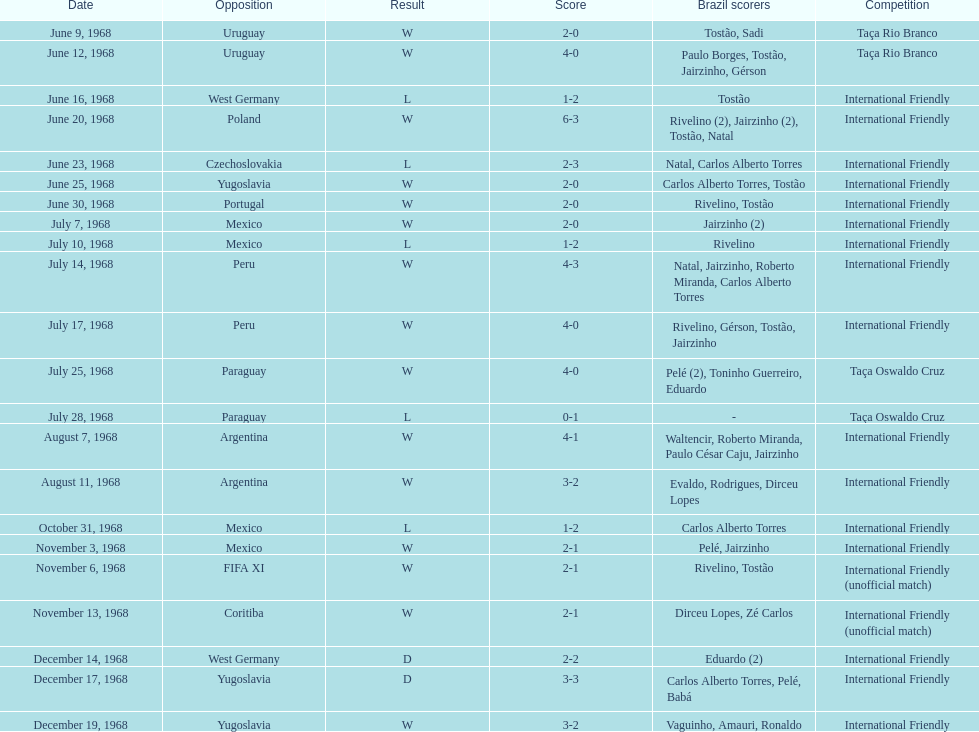What's the total number of ties? 2. 